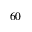<formula> <loc_0><loc_0><loc_500><loc_500>6 0</formula> 